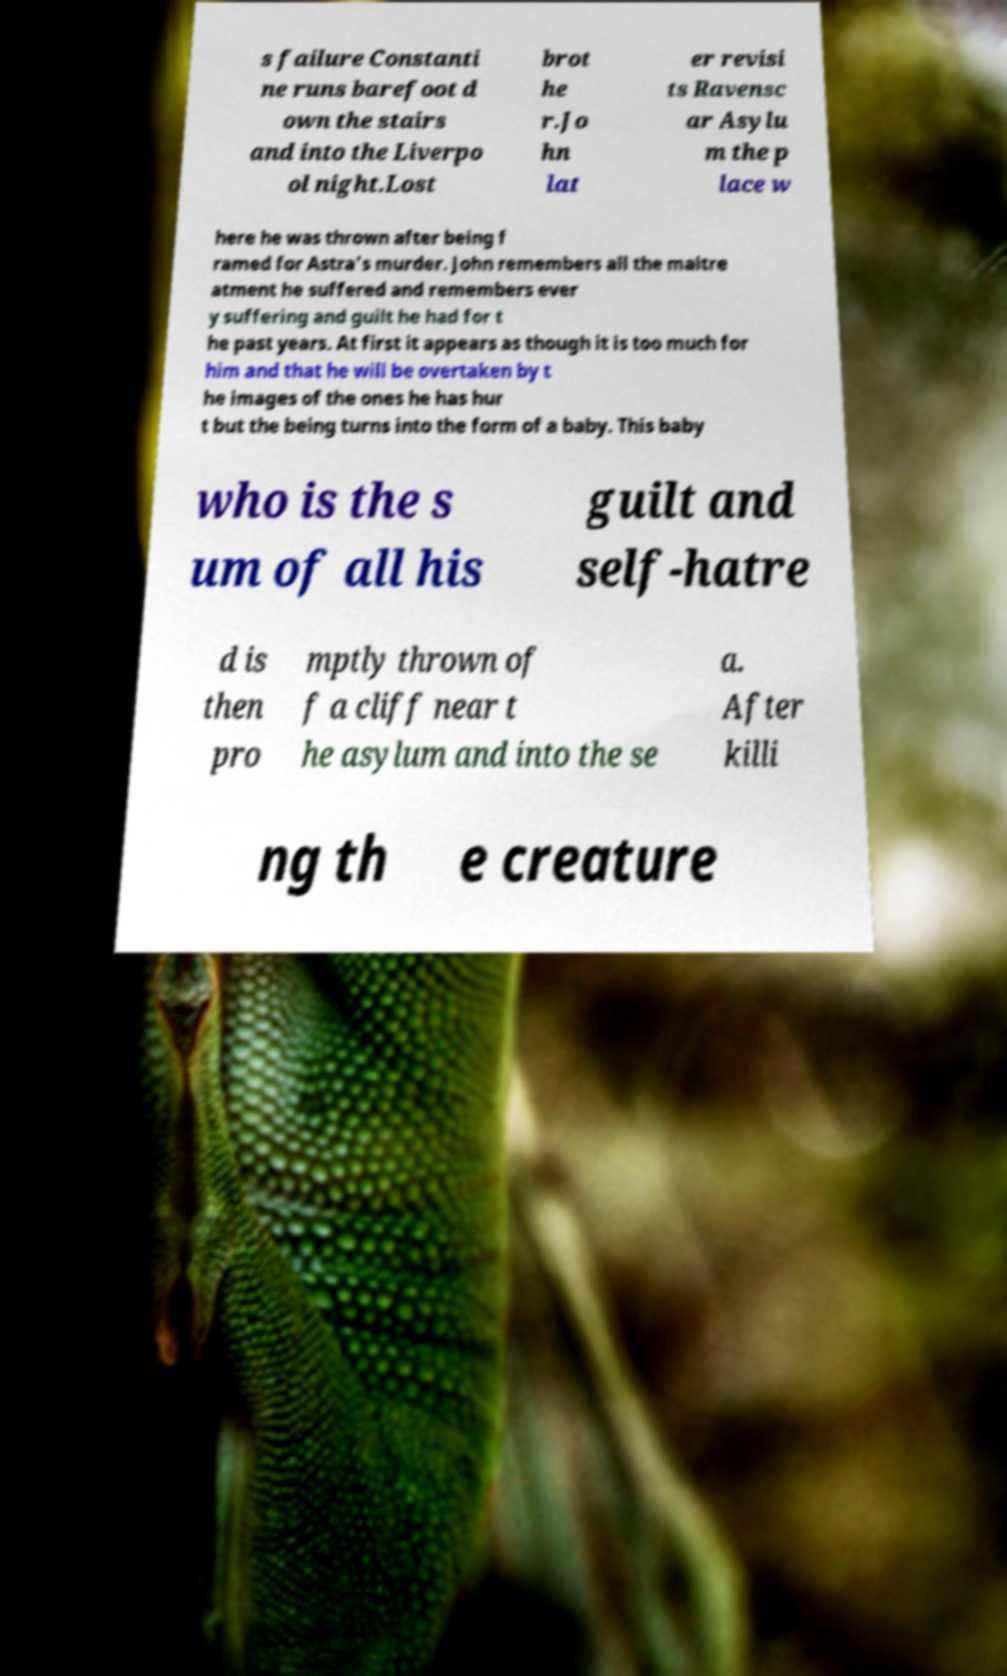What messages or text are displayed in this image? I need them in a readable, typed format. s failure Constanti ne runs barefoot d own the stairs and into the Liverpo ol night.Lost brot he r.Jo hn lat er revisi ts Ravensc ar Asylu m the p lace w here he was thrown after being f ramed for Astra's murder. John remembers all the maltre atment he suffered and remembers ever y suffering and guilt he had for t he past years. At first it appears as though it is too much for him and that he will be overtaken by t he images of the ones he has hur t but the being turns into the form of a baby. This baby who is the s um of all his guilt and self-hatre d is then pro mptly thrown of f a cliff near t he asylum and into the se a. After killi ng th e creature 